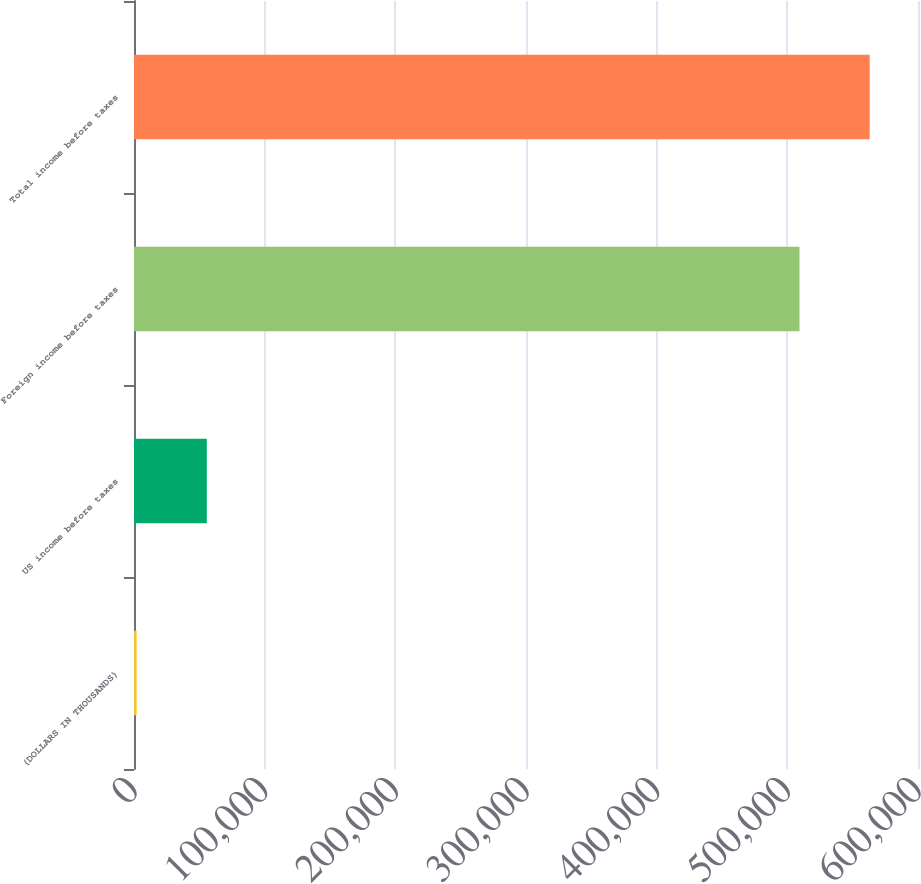<chart> <loc_0><loc_0><loc_500><loc_500><bar_chart><fcel>(DOLLARS IN THOUSANDS)<fcel>US income before taxes<fcel>Foreign income before taxes<fcel>Total income before taxes<nl><fcel>2015<fcel>55723.6<fcel>509309<fcel>563018<nl></chart> 